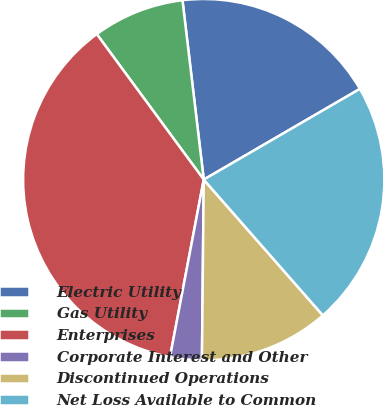<chart> <loc_0><loc_0><loc_500><loc_500><pie_chart><fcel>Electric Utility<fcel>Gas Utility<fcel>Enterprises<fcel>Corporate Interest and Other<fcel>Discontinued Operations<fcel>Net Loss Available to Common<nl><fcel>18.5%<fcel>8.21%<fcel>36.91%<fcel>2.83%<fcel>11.62%<fcel>21.91%<nl></chart> 